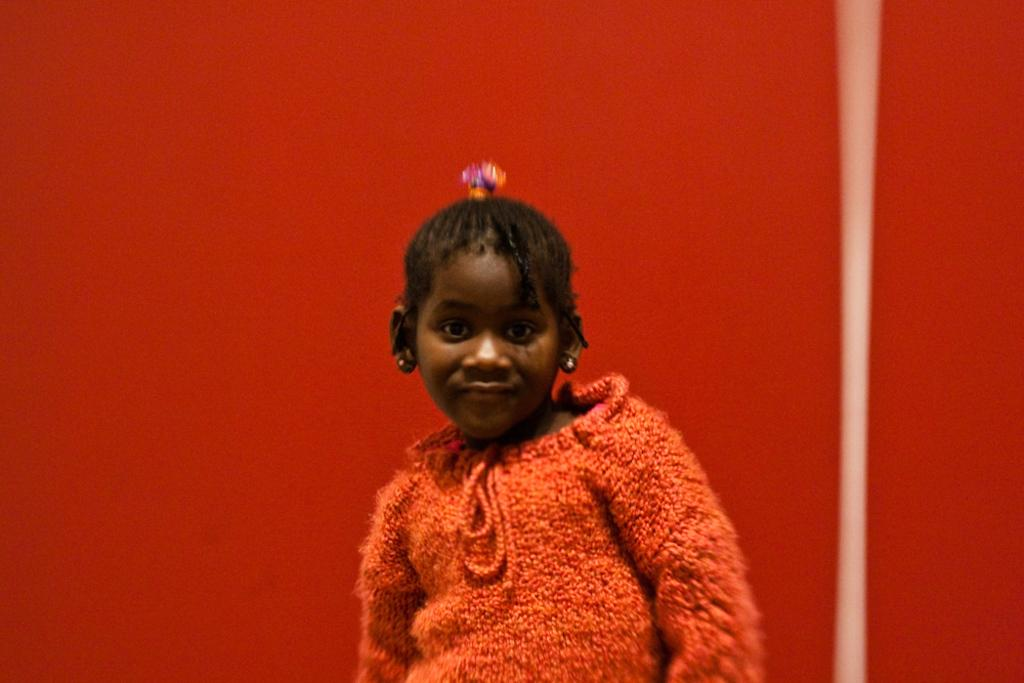What is the main subject of the image? The main subject of the image is a girl. What is the girl wearing in the image? The girl is wearing a red dress. What can be seen behind the girl in the image? There is a red color wall behind the girl. Can you see any fairies flying around the girl in the image? There are no fairies visible in the image. Is the girl's parent present in the image? The provided facts do not mention the presence of a parent in the image. 